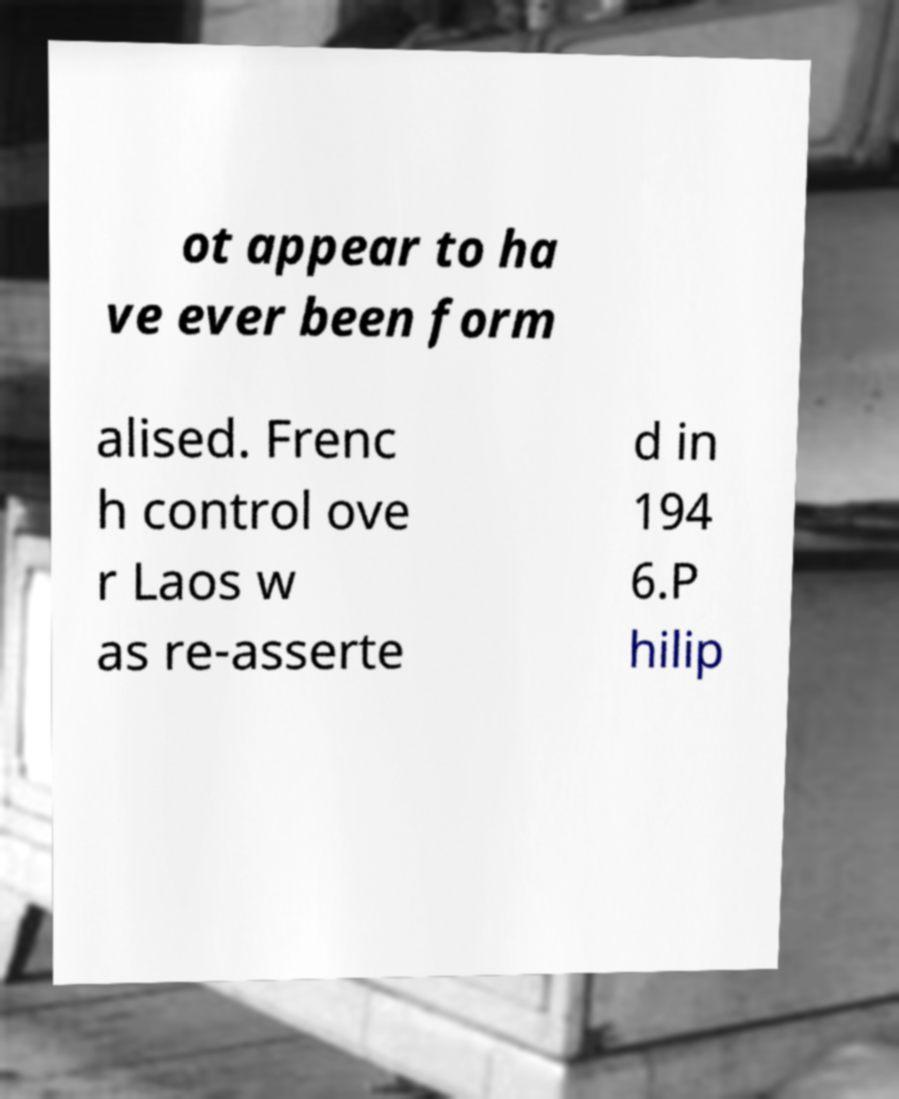Please identify and transcribe the text found in this image. ot appear to ha ve ever been form alised. Frenc h control ove r Laos w as re-asserte d in 194 6.P hilip 